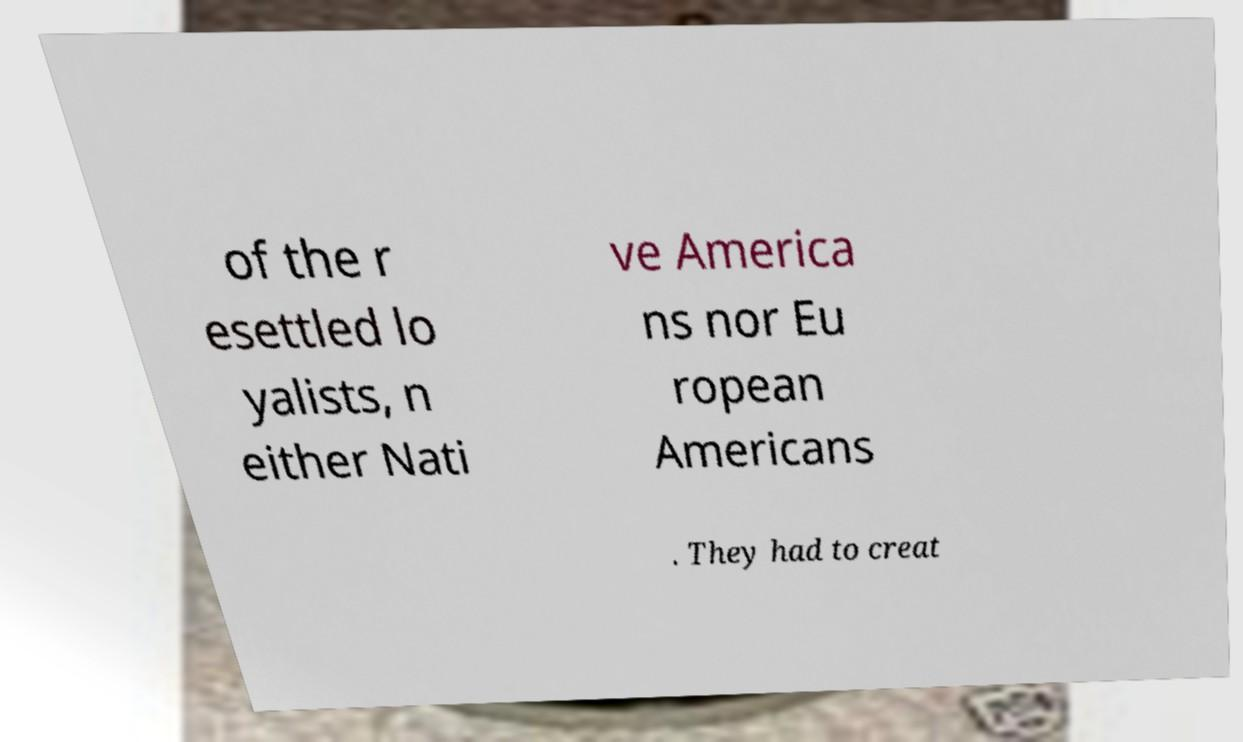What messages or text are displayed in this image? I need them in a readable, typed format. of the r esettled lo yalists, n either Nati ve America ns nor Eu ropean Americans . They had to creat 